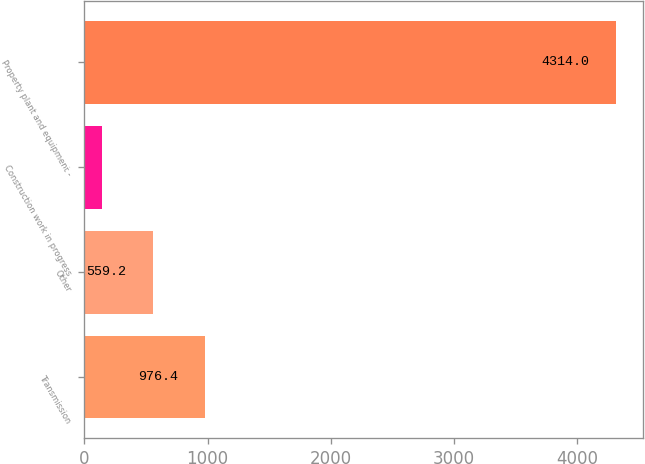Convert chart to OTSL. <chart><loc_0><loc_0><loc_500><loc_500><bar_chart><fcel>Transmission<fcel>Other<fcel>Construction work in progress<fcel>Property plant and equipment -<nl><fcel>976.4<fcel>559.2<fcel>142<fcel>4314<nl></chart> 